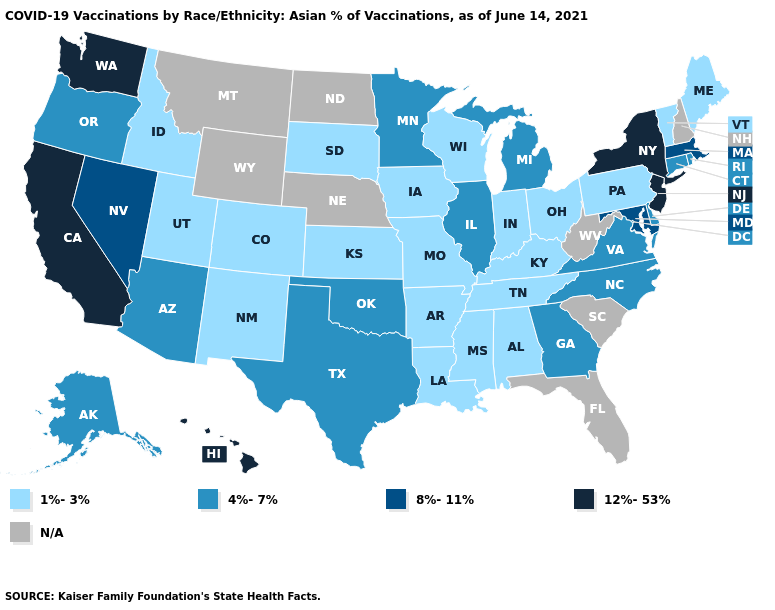Name the states that have a value in the range N/A?
Write a very short answer. Florida, Montana, Nebraska, New Hampshire, North Dakota, South Carolina, West Virginia, Wyoming. Name the states that have a value in the range 4%-7%?
Concise answer only. Alaska, Arizona, Connecticut, Delaware, Georgia, Illinois, Michigan, Minnesota, North Carolina, Oklahoma, Oregon, Rhode Island, Texas, Virginia. Does Minnesota have the highest value in the MidWest?
Quick response, please. Yes. Does the first symbol in the legend represent the smallest category?
Answer briefly. Yes. What is the highest value in the MidWest ?
Write a very short answer. 4%-7%. Name the states that have a value in the range N/A?
Concise answer only. Florida, Montana, Nebraska, New Hampshire, North Dakota, South Carolina, West Virginia, Wyoming. What is the value of North Carolina?
Be succinct. 4%-7%. Is the legend a continuous bar?
Quick response, please. No. Which states have the lowest value in the USA?
Quick response, please. Alabama, Arkansas, Colorado, Idaho, Indiana, Iowa, Kansas, Kentucky, Louisiana, Maine, Mississippi, Missouri, New Mexico, Ohio, Pennsylvania, South Dakota, Tennessee, Utah, Vermont, Wisconsin. Name the states that have a value in the range 12%-53%?
Give a very brief answer. California, Hawaii, New Jersey, New York, Washington. Does the map have missing data?
Concise answer only. Yes. Is the legend a continuous bar?
Be succinct. No. Does South Dakota have the highest value in the MidWest?
Short answer required. No. What is the value of Nebraska?
Concise answer only. N/A. 